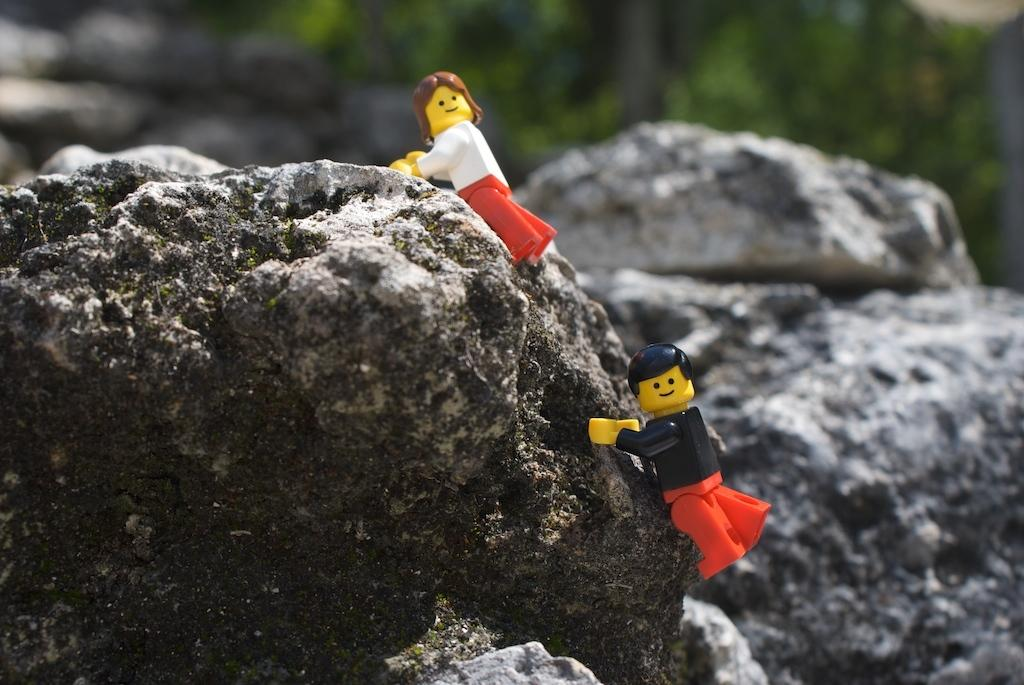What type of objects can be seen in the image? There are stones and Lego pieces in the image. What color is the background of the image? The background of the image has a green color. How would you describe the quality of the image? The image is slightly blurry in the background. Can you see a toothbrush being used on the stones in the image? There is no toothbrush present in the image, and the stones are not being used with any tool. 